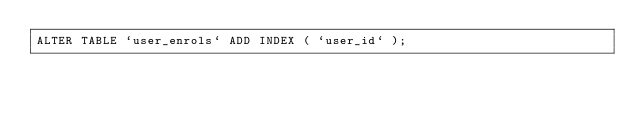Convert code to text. <code><loc_0><loc_0><loc_500><loc_500><_SQL_>ALTER TABLE `user_enrols` ADD INDEX ( `user_id` );
</code> 